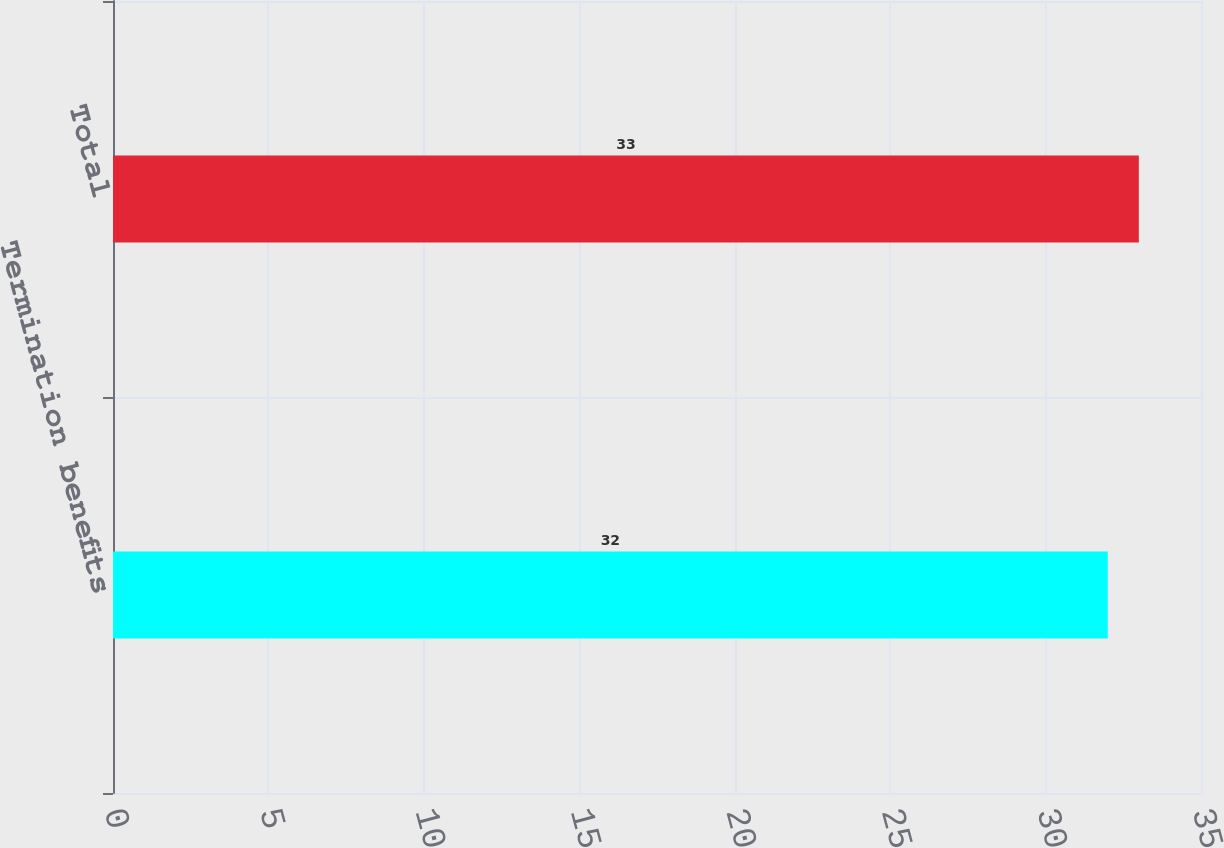Convert chart. <chart><loc_0><loc_0><loc_500><loc_500><bar_chart><fcel>Termination benefits<fcel>Total<nl><fcel>32<fcel>33<nl></chart> 